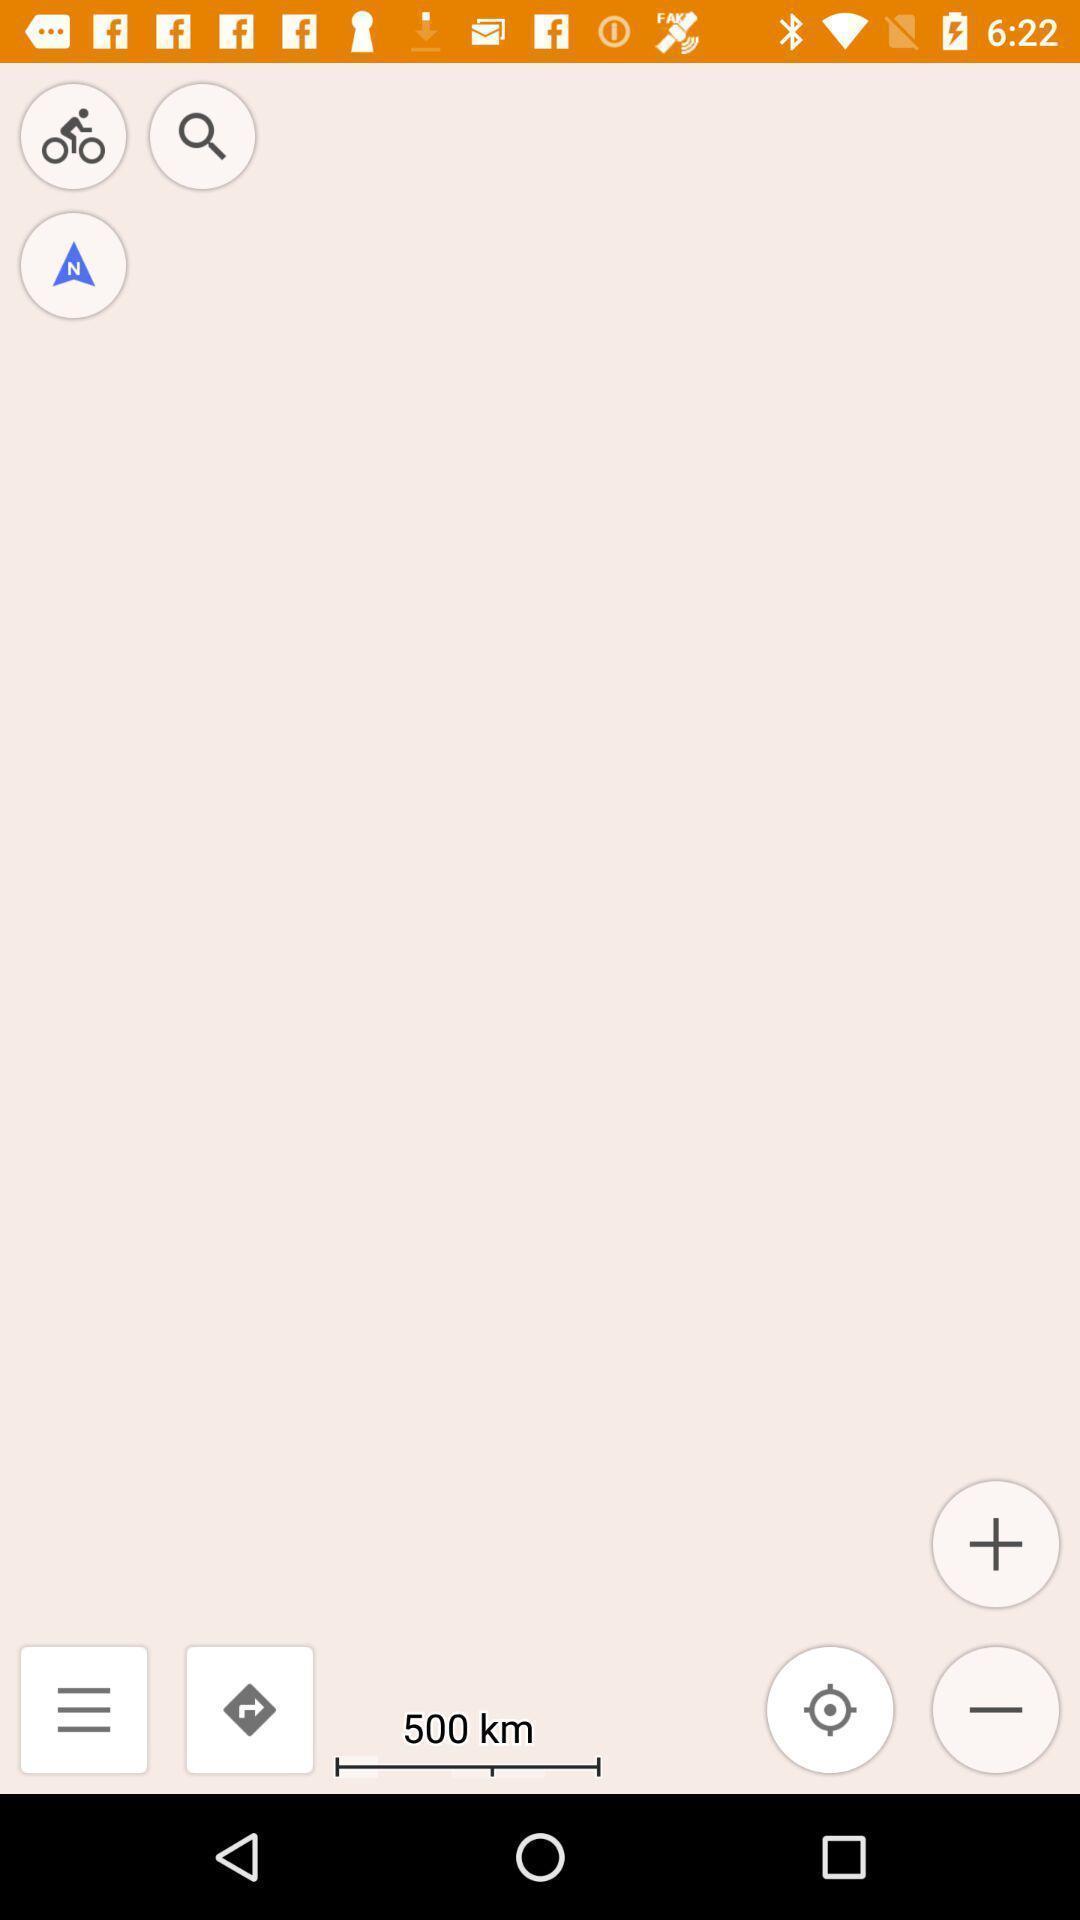Describe the key features of this screenshot. Page displaying various icons like search bar. 